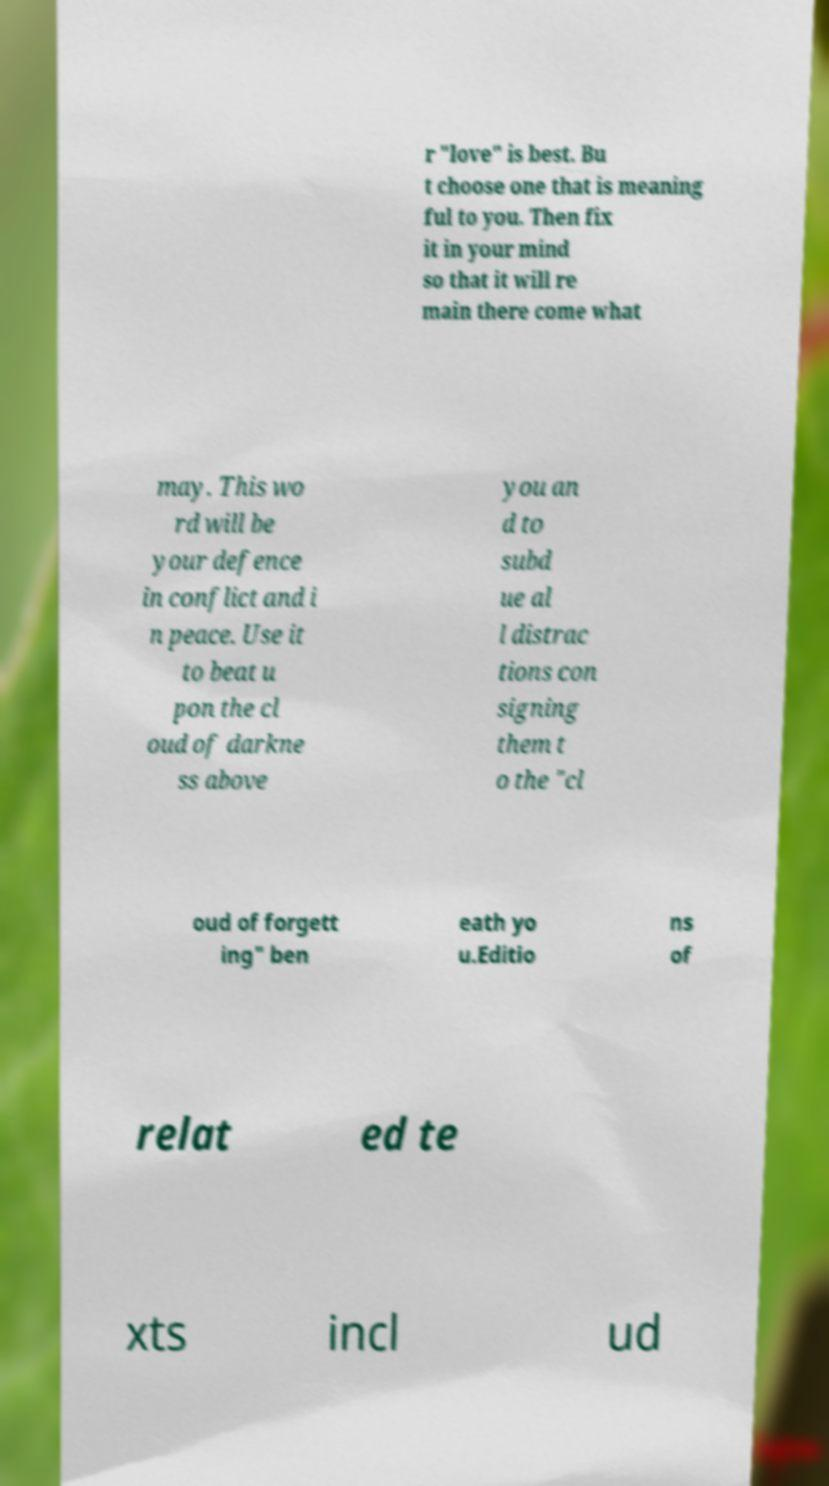What messages or text are displayed in this image? I need them in a readable, typed format. r "love" is best. Bu t choose one that is meaning ful to you. Then fix it in your mind so that it will re main there come what may. This wo rd will be your defence in conflict and i n peace. Use it to beat u pon the cl oud of darkne ss above you an d to subd ue al l distrac tions con signing them t o the "cl oud of forgett ing" ben eath yo u.Editio ns of relat ed te xts incl ud 